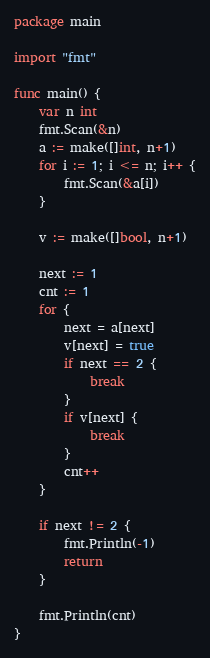<code> <loc_0><loc_0><loc_500><loc_500><_Go_>package main

import "fmt"

func main() {
	var n int
	fmt.Scan(&n)
	a := make([]int, n+1)
	for i := 1; i <= n; i++ {
		fmt.Scan(&a[i])
	}

	v := make([]bool, n+1)

	next := 1
	cnt := 1
	for {
		next = a[next]
		v[next] = true
		if next == 2 {
			break
		}
		if v[next] {
			break
		}
		cnt++
	}

	if next != 2 {
		fmt.Println(-1)
		return
	}

	fmt.Println(cnt)
}</code> 